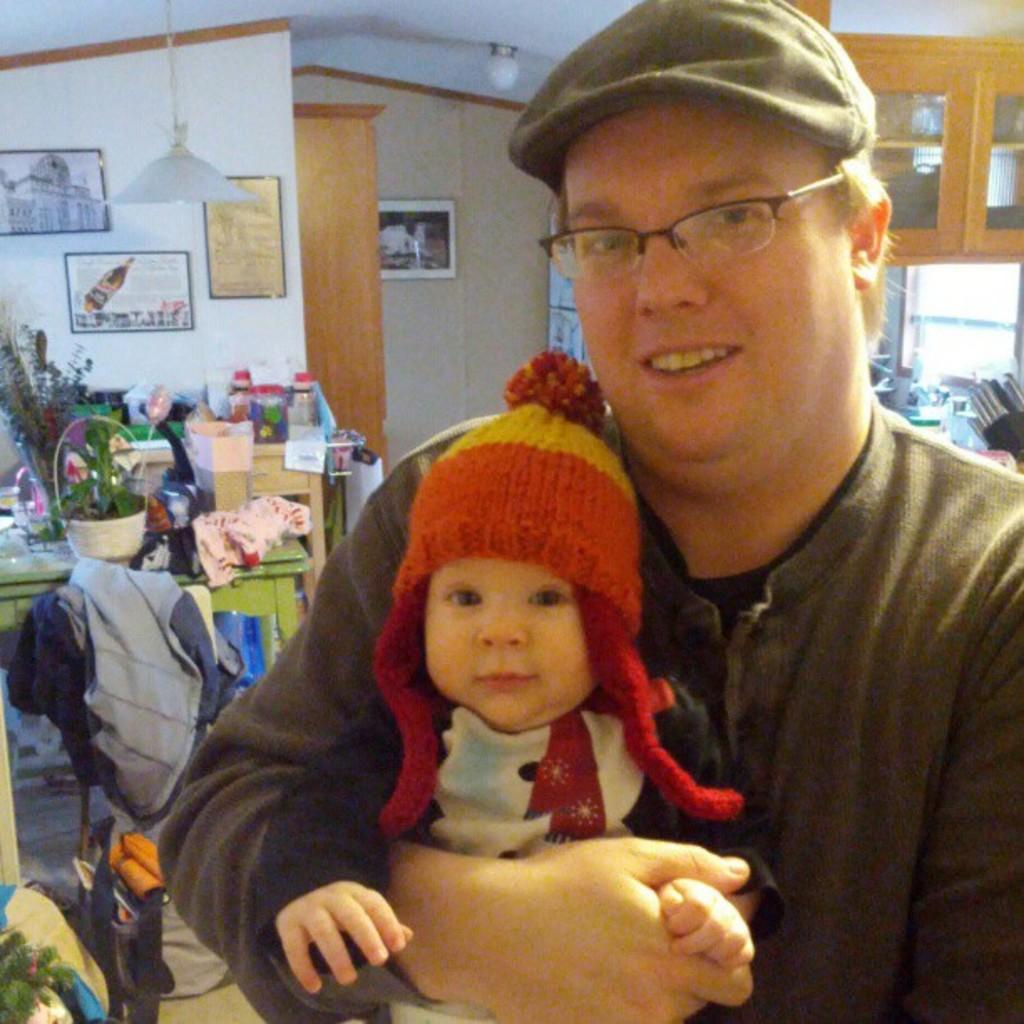Describe this image in one or two sentences. In this image in the foreground a woman holding a baby behind her there is the wall, on the wall there are photo frames attached, on the left side there is a table , on which there is a cloth, flower pots, plants, bottle, in front of table there is a chair, on which there is a cloth, there is a cupboard visible in the top right, there are some other objects visible behind her. 